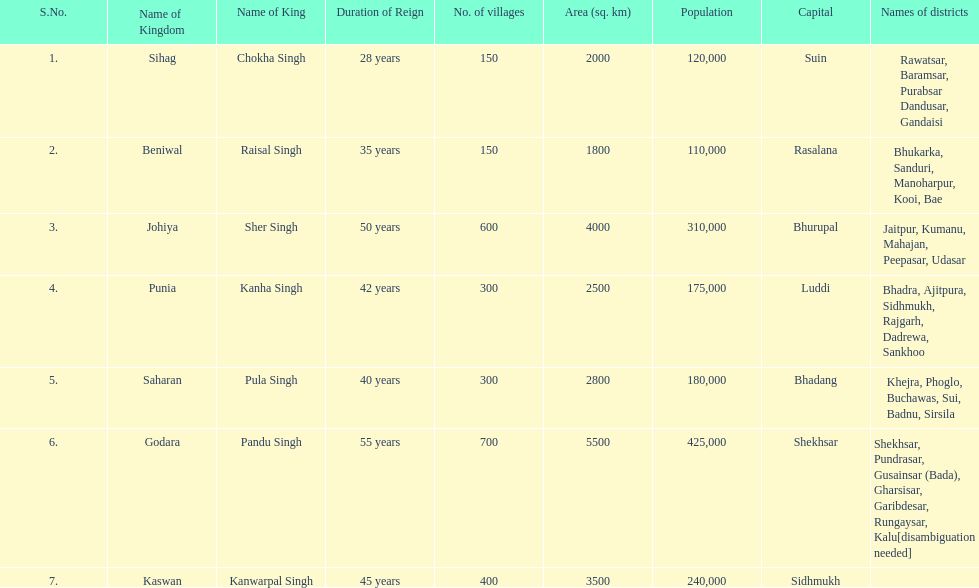What is the number of kingdoms that have more than 300 villages? 3. 